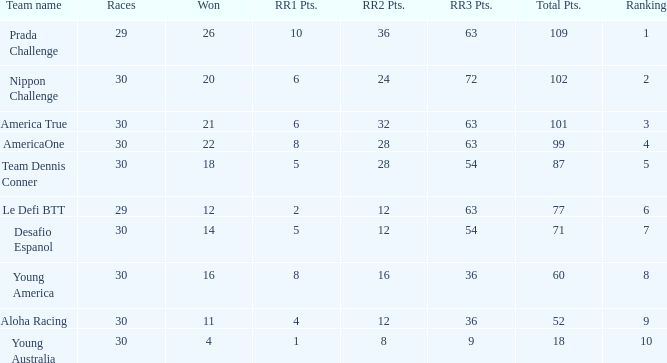State the aggregate quantity of rr2 points for 11 successful outcomes. 1.0. 